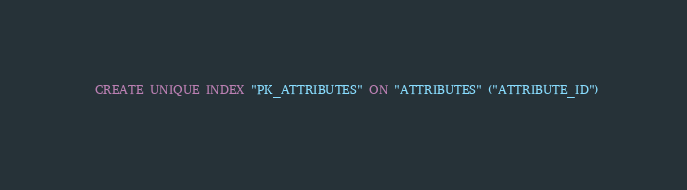<code> <loc_0><loc_0><loc_500><loc_500><_SQL_>
  CREATE UNIQUE INDEX "PK_ATTRIBUTES" ON "ATTRIBUTES" ("ATTRIBUTE_ID") 
  </code> 